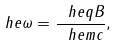Convert formula to latex. <formula><loc_0><loc_0><loc_500><loc_500>\ h e \omega = \frac { \ h e q B } { \ h e m c } ,</formula> 